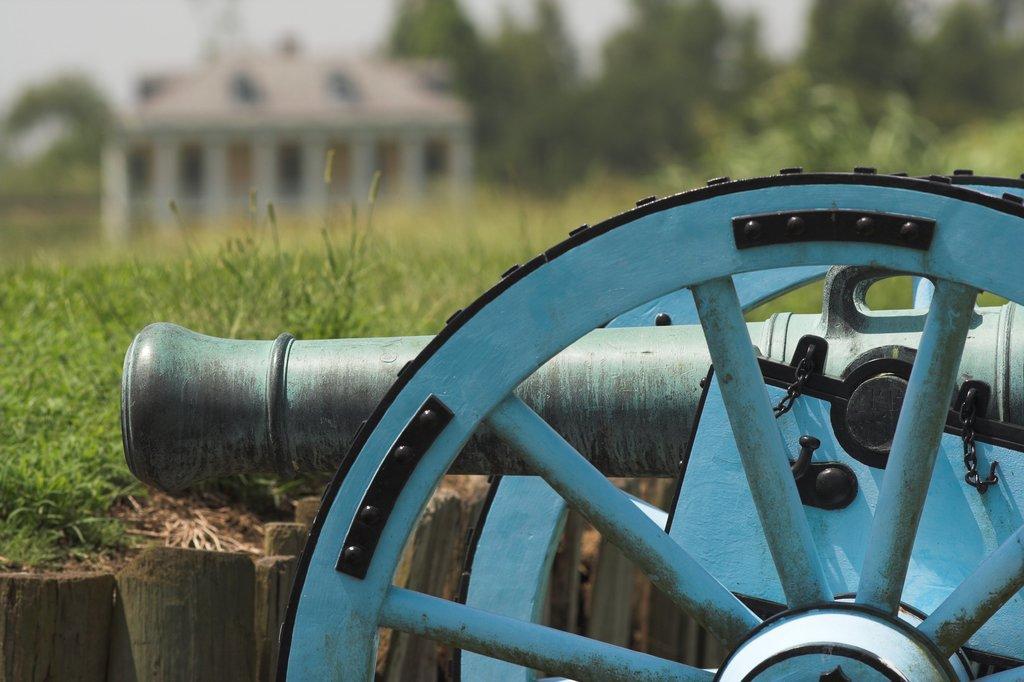How would you summarize this image in a sentence or two? In this image in the foreground there are wheels, iron poles, on wheels there are spokes, at the bottom there wooden logs, in the middle there is a building, trees, at the top there is the sky. 